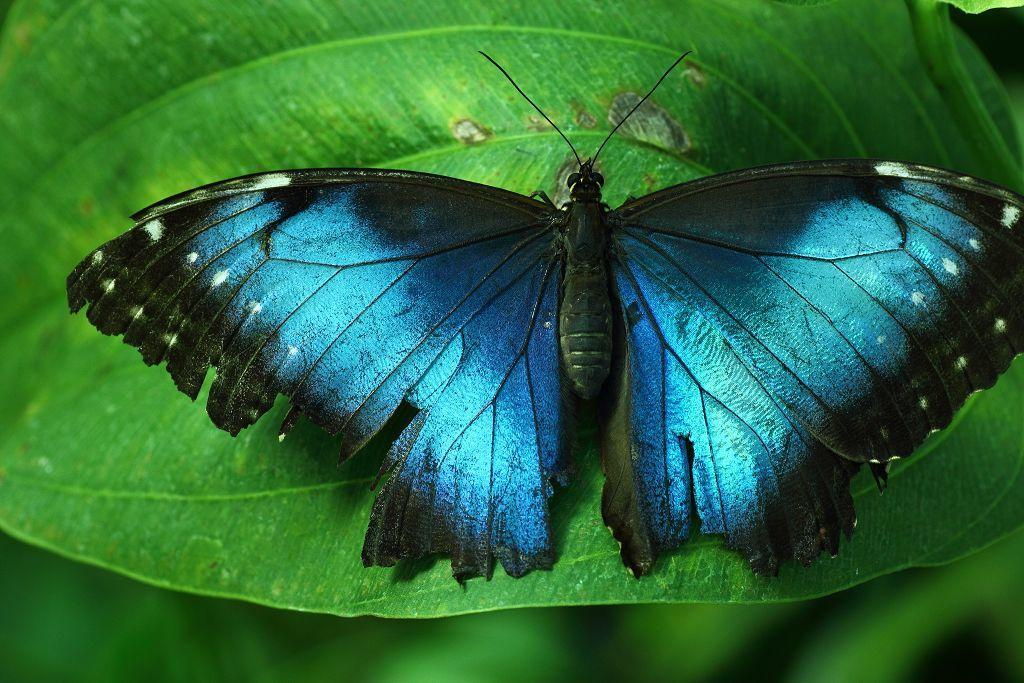What is the main subject of the image? The main subject of the image is a butterfly. Where is the butterfly located in the image? The butterfly is on a leaf. What type of waste is visible in the image? There is no waste visible in the image; it features a butterfly on a leaf. What is the butterfly using as fuel in the image? Butterflies do not use fuel; they obtain energy from the nectar of flowers. 